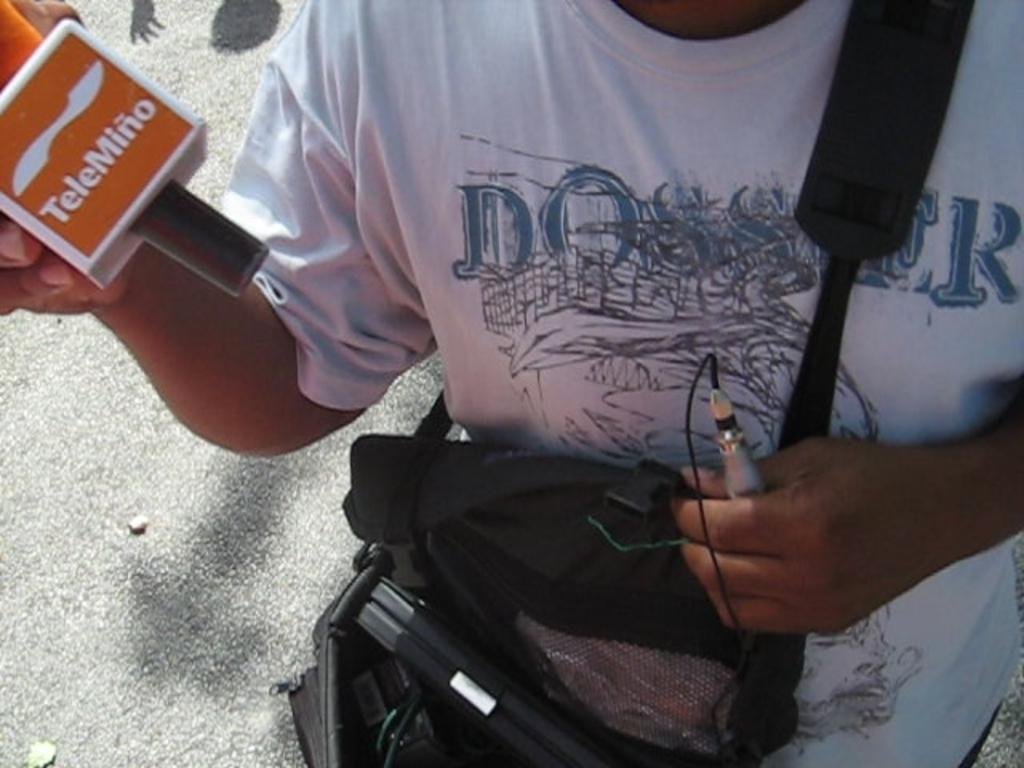Who or what is present in the image? There is a person in the image. What is the person holding in one hand? The person is holding a microphone in one hand. What is the person holding in the other hand? The person is holding a device in the other hand. What is the person carrying in the image? The person is carrying a bag containing objects. What type of coil can be seen in the image? There is no coil present in the image. Which direction is the person facing in the image? The provided facts do not indicate the direction the person is facing. 